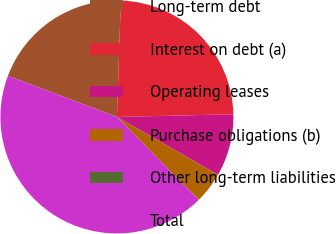Convert chart. <chart><loc_0><loc_0><loc_500><loc_500><pie_chart><fcel>Long-term debt<fcel>Interest on debt (a)<fcel>Operating leases<fcel>Purchase obligations (b)<fcel>Other long-term liabilities<fcel>Total<nl><fcel>19.79%<fcel>24.1%<fcel>8.64%<fcel>4.32%<fcel>0.01%<fcel>43.13%<nl></chart> 